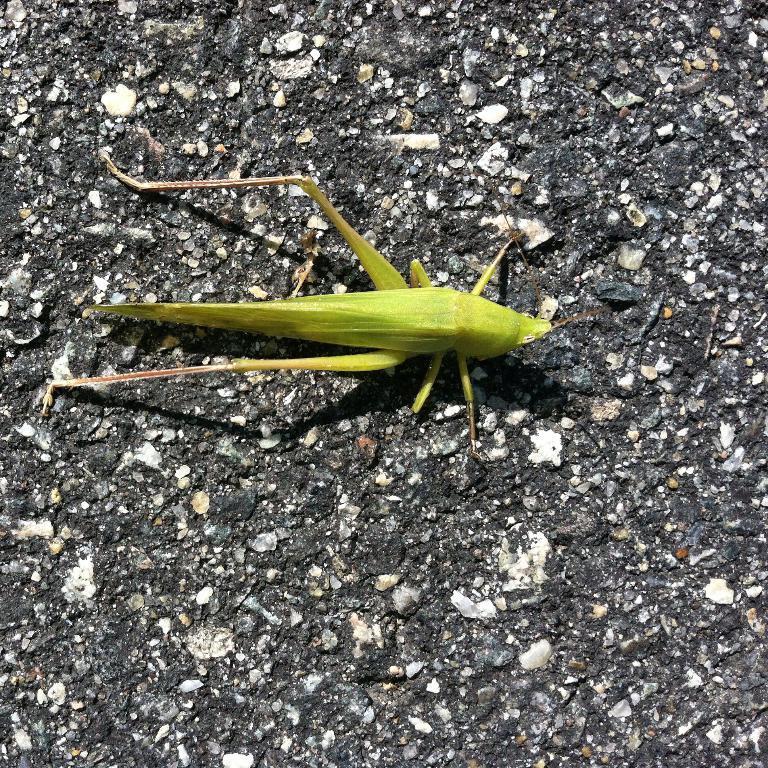How would you summarize this image in a sentence or two? We can see green insect on the surface. 